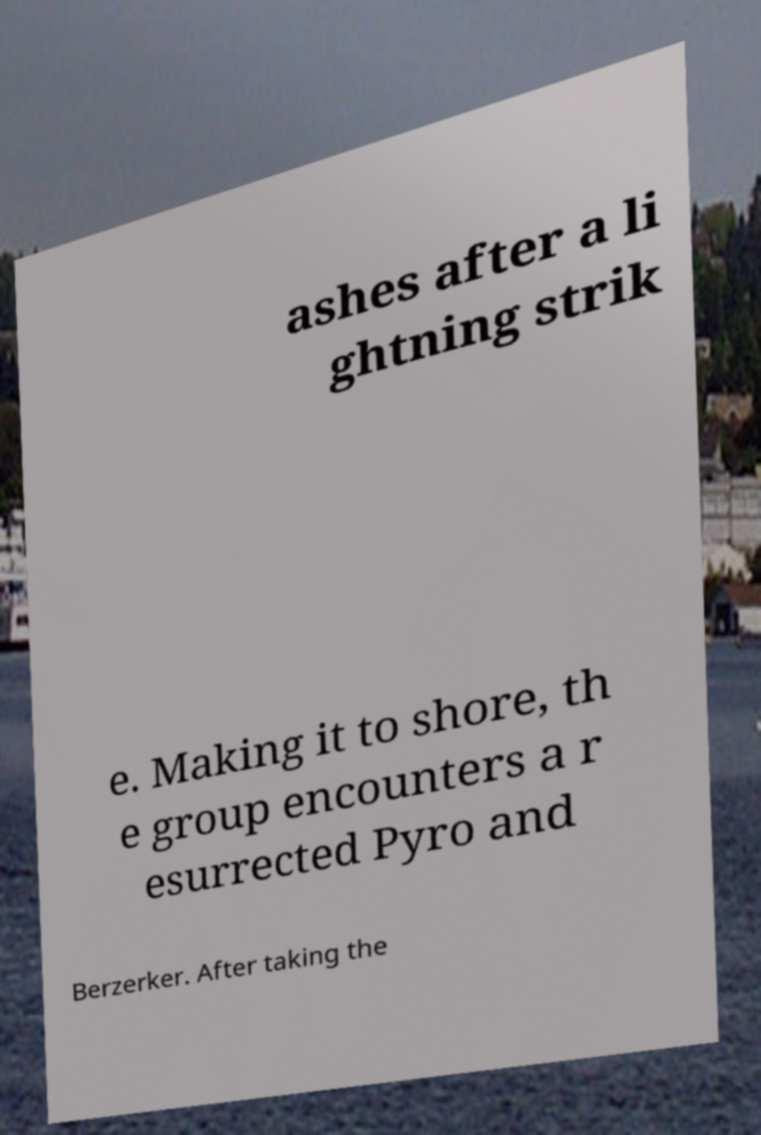Could you assist in decoding the text presented in this image and type it out clearly? ashes after a li ghtning strik e. Making it to shore, th e group encounters a r esurrected Pyro and Berzerker. After taking the 